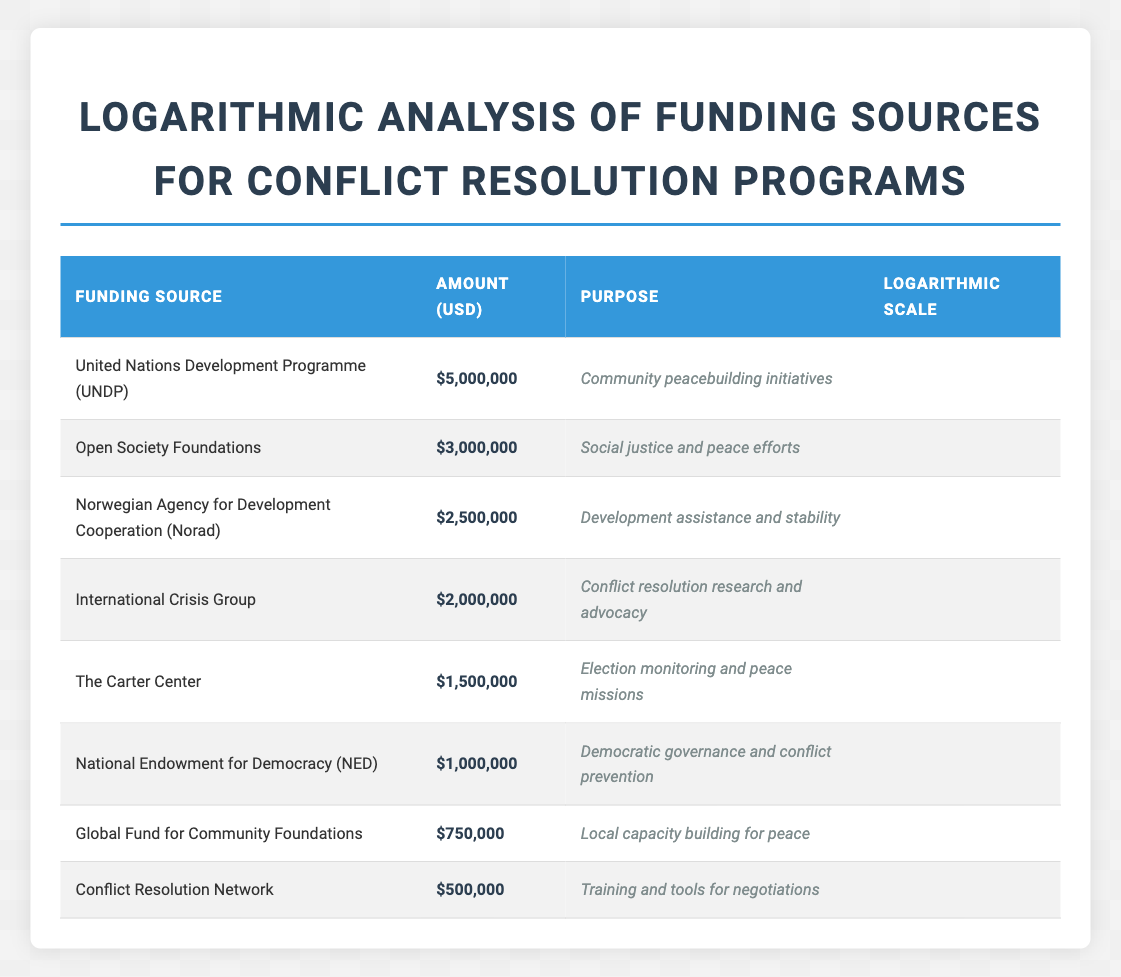What is the largest funding source for conflict resolution programs? The largest funding source can be identified by looking for the highest amount in the table. The top entry shows "United Nations Development Programme (UNDP)" with an amount of $5,000,000.
Answer: $5,000,000 Which organization provides funding specifically for training and tools for negotiations? By scanning the table, we see that "Conflict Resolution Network" is listed with the purpose "Training and tools for negotiations."
Answer: Conflict Resolution Network What is the total amount of funding from the top three highest sources? To determine this, we add the amounts from the top three entries: $5,000,000 (UNDP) + $3,000,000 (Open Society Foundations) + $2,500,000 (Norad) = $10,500,000.
Answer: $10,500,000 Is the funding amount from the Global Fund for Community Foundations greater than $800,000? Looking at the Global Fund for Community Foundations, it shows an amount of $750,000, which is less than $800,000. Thus, the answer is no.
Answer: No What is the purpose of the funding from the Norwegian Agency for Development Cooperation? The purpose is listed clearly in the table next to its funding amount, which states "Development assistance and stability."
Answer: Development assistance and stability What percentage of the total funding is allocated for community peacebuilding initiatives compared to the total amount? First, we note that the total funding is $18,000,000 (sum of all sources). The funding for community peacebuilding initiatives is $5,000,000 from UNDP. To find the percentage: ($5,000,000 / $18,000,000) * 100 ≈ 27.78%.
Answer: Approximately 27.78% Which funding source has a purpose directly related to democratic governance? We find that the "National Endowment for Democracy (NED)" explicitly mentions its purpose as "Democratic governance and conflict prevention."
Answer: National Endowment for Democracy (NED) If we were to consider only the foundations, what is the total funding amount they provide? The foundations included in the table are the "Open Society Foundations" ($3,000,000), "Global Fund for Community Foundations" ($750,000), and "Conflict Resolution Network" ($500,000). Adding these amounts gives: $3,000,000 + $750,000 + $500,000 = $4,250,000.
Answer: $4,250,000 